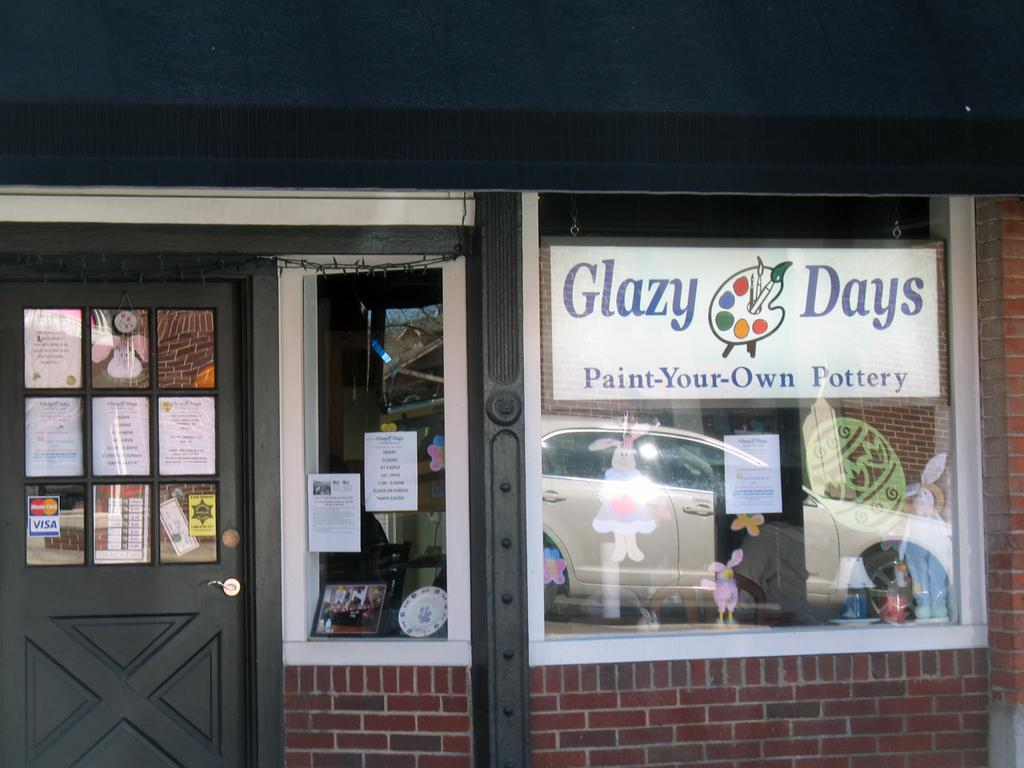What type of structure can be seen in the image? There is a wall in the image. Is there an entrance visible in the image? Yes, there is a door in the image. What type of decorations are present on the wall? There are posters and stickers in the image. What material is used for the windows in the image? The windows in the image are made of glass. What can be seen through the glass windows? A vehicle is visible through the glass windows. How many snakes are slithering on the wall in the image? There are no snakes present in the image. Is there a visitor visible in the image? The image does not show any visitors; it only features the wall, door, posters, stickers, windows, and the vehicle visible through the windows. 